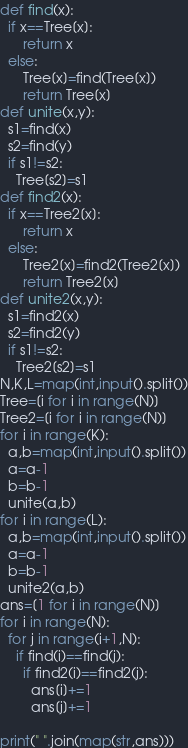Convert code to text. <code><loc_0><loc_0><loc_500><loc_500><_Python_>def find(x):
  if x==Tree[x]:
      return x
  else:
      Tree[x]=find(Tree[x])
      return Tree[x]
def unite(x,y):
  s1=find(x)
  s2=find(y)
  if s1!=s2:
    Tree[s2]=s1
def find2(x):
  if x==Tree2[x]:
      return x
  else:
      Tree2[x]=find2(Tree2[x])
      return Tree2[x]
def unite2(x,y):
  s1=find2(x)
  s2=find2(y)
  if s1!=s2:
    Tree2[s2]=s1
N,K,L=map(int,input().split())
Tree=[i for i in range(N)]
Tree2=[i for i in range(N)]
for i in range(K):
  a,b=map(int,input().split())
  a=a-1
  b=b-1
  unite(a,b)
for i in range(L):
  a,b=map(int,input().split())
  a=a-1
  b=b-1
  unite2(a,b)
ans=[1 for i in range(N)]
for i in range(N):
  for j in range(i+1,N):
    if find(i)==find(j):
      if find2(i)==find2(j):
        ans[i]+=1
        ans[j]+=1
        
print(" ".join(map(str,ans)))</code> 